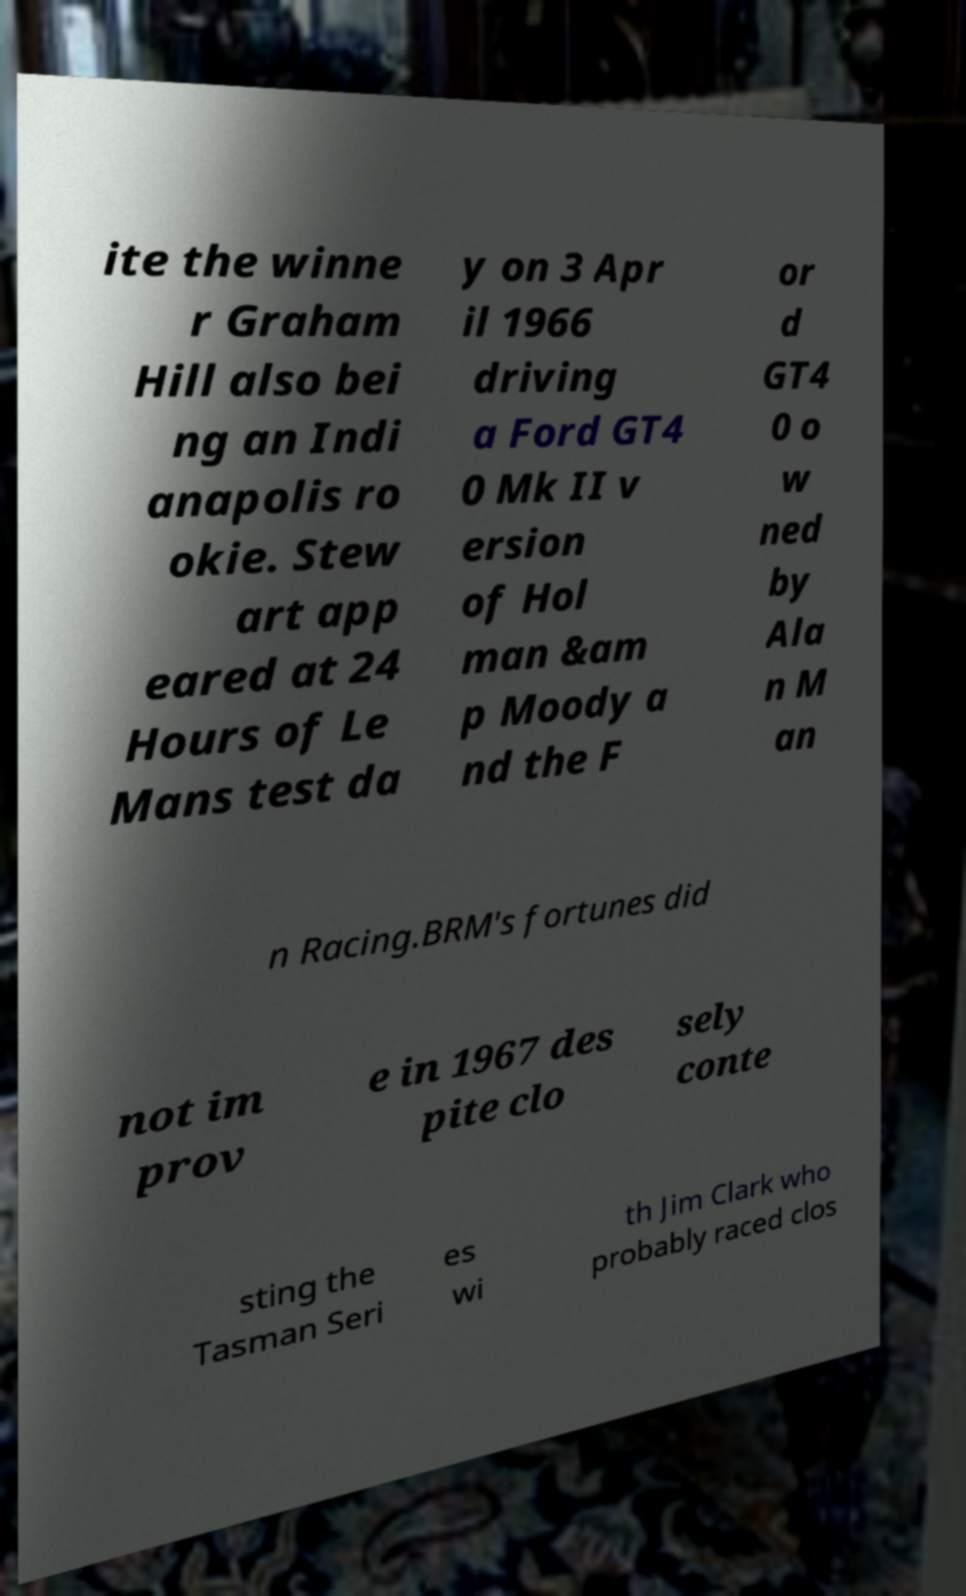Can you accurately transcribe the text from the provided image for me? ite the winne r Graham Hill also bei ng an Indi anapolis ro okie. Stew art app eared at 24 Hours of Le Mans test da y on 3 Apr il 1966 driving a Ford GT4 0 Mk II v ersion of Hol man &am p Moody a nd the F or d GT4 0 o w ned by Ala n M an n Racing.BRM's fortunes did not im prov e in 1967 des pite clo sely conte sting the Tasman Seri es wi th Jim Clark who probably raced clos 